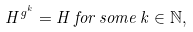Convert formula to latex. <formula><loc_0><loc_0><loc_500><loc_500>H ^ { g ^ { k } } = H \, f o r \, s o m e \, k \in \mathbb { N } ,</formula> 